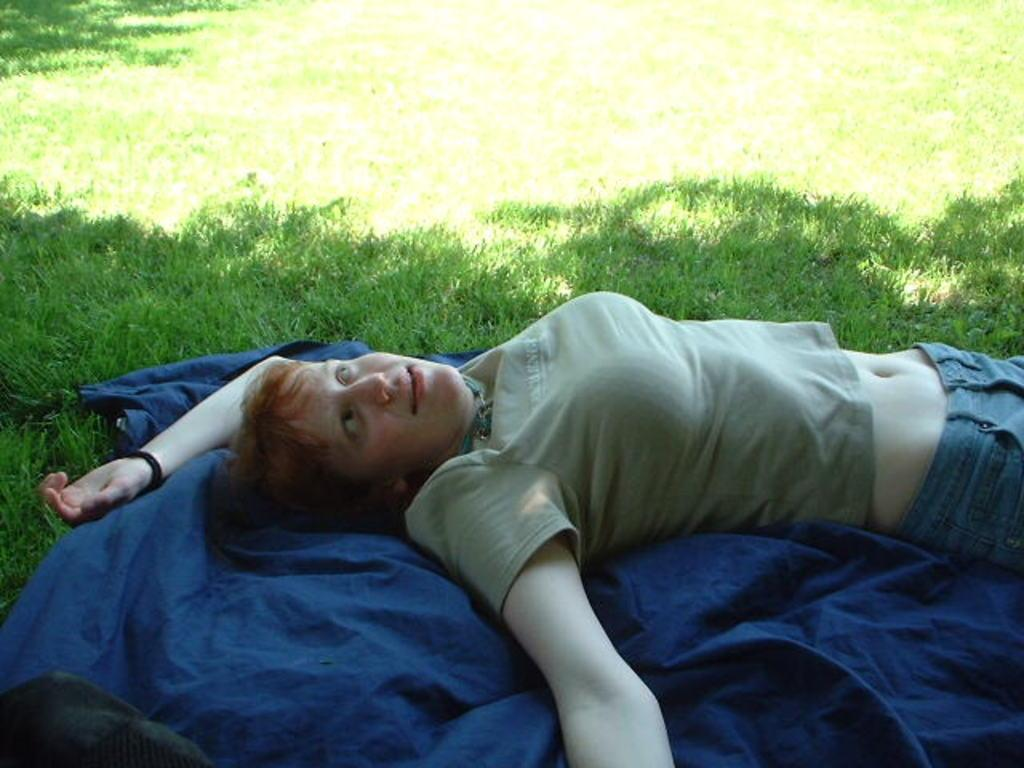Who is present in the image? There is a woman in the image. What is the woman lying on? The woman is lying on a blue colored cloth. What type of vegetation can be seen in the image? The grass is visible in the image. What type of clothing is the woman wearing? The woman is wearing a T-shirt. What type of liquid can be seen dripping from the woman's T-shirt in the image? There is no liquid visible on the woman's T-shirt in the image. 